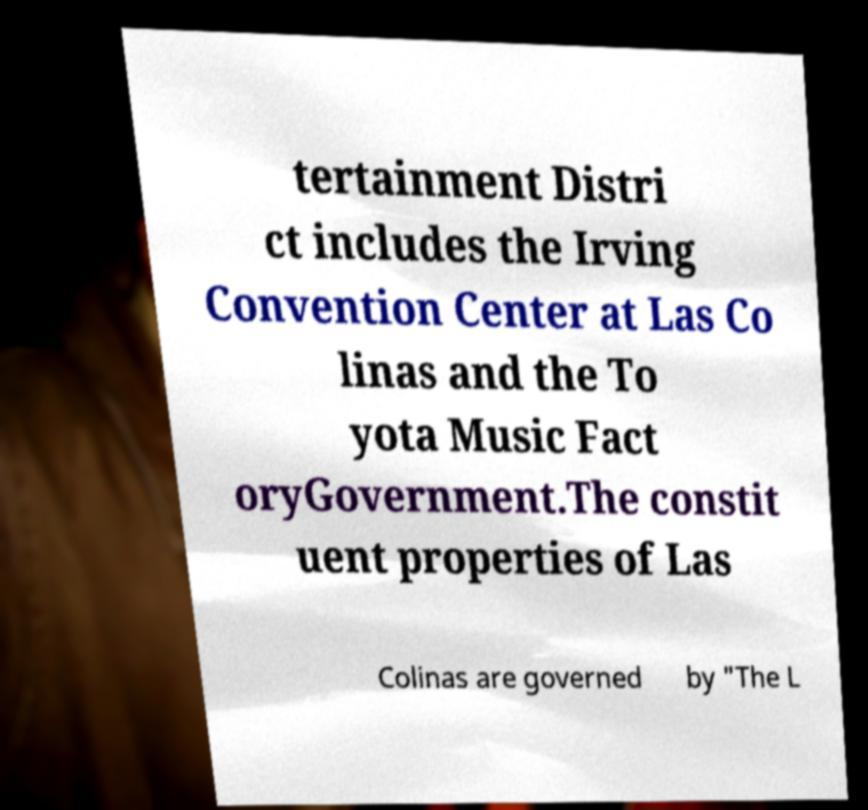There's text embedded in this image that I need extracted. Can you transcribe it verbatim? tertainment Distri ct includes the Irving Convention Center at Las Co linas and the To yota Music Fact oryGovernment.The constit uent properties of Las Colinas are governed by "The L 